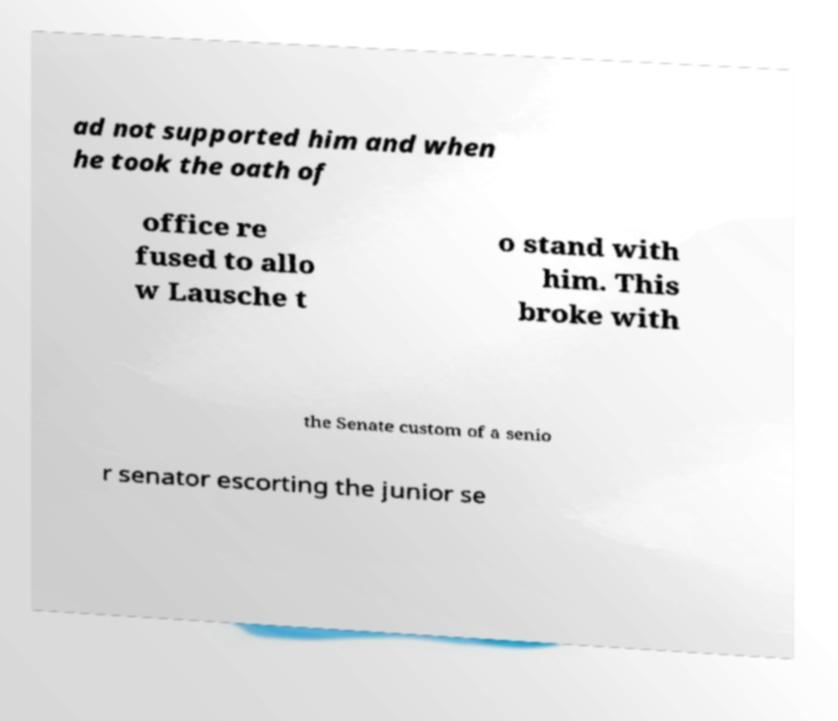Can you read and provide the text displayed in the image?This photo seems to have some interesting text. Can you extract and type it out for me? ad not supported him and when he took the oath of office re fused to allo w Lausche t o stand with him. This broke with the Senate custom of a senio r senator escorting the junior se 